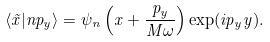<formula> <loc_0><loc_0><loc_500><loc_500>\langle \vec { x } | n p _ { y } \rangle = \psi _ { n } \left ( x + \frac { p _ { y } } { M \omega } \right ) \exp ( i p _ { y } y ) .</formula> 